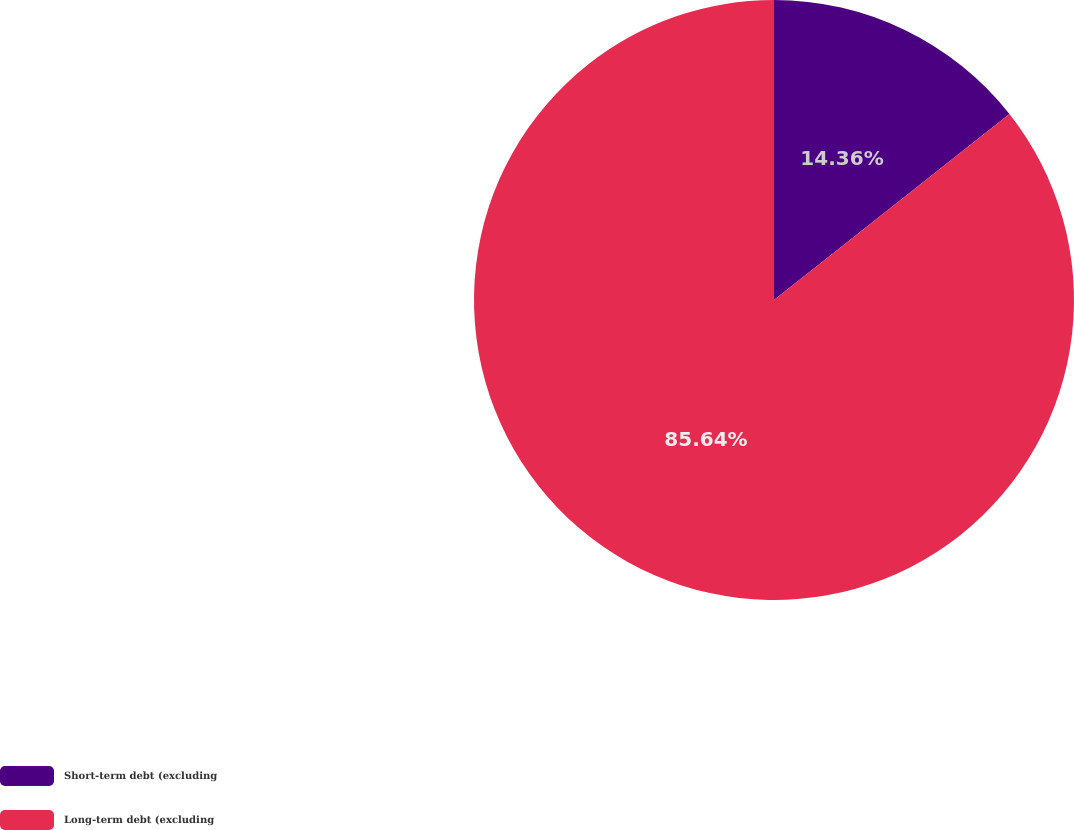Convert chart. <chart><loc_0><loc_0><loc_500><loc_500><pie_chart><fcel>Short-term debt (excluding<fcel>Long-term debt (excluding<nl><fcel>14.36%<fcel>85.64%<nl></chart> 